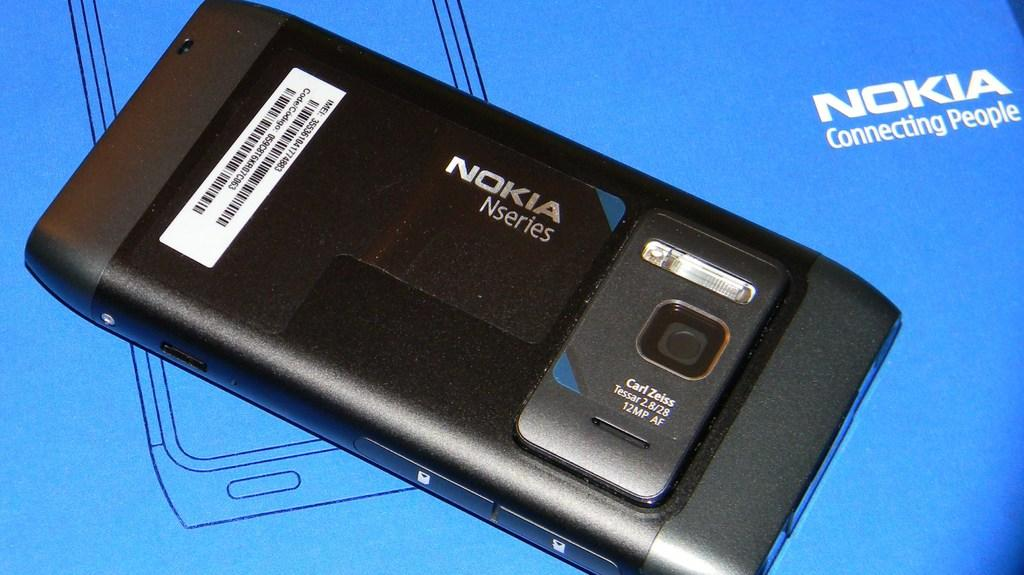<image>
Create a compact narrative representing the image presented. A black Nokia NSeries phone is being displayed. 